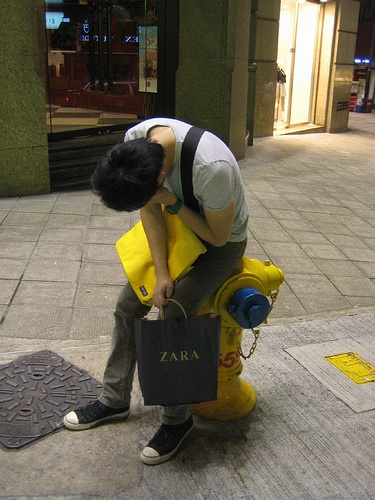Describe the objects in this image and their specific colors. I can see people in darkgreen, black, gray, olive, and lightgray tones, handbag in darkgreen, black, olive, and gray tones, fire hydrant in darkgreen, olive, and black tones, and handbag in darkgreen, gold, and olive tones in this image. 